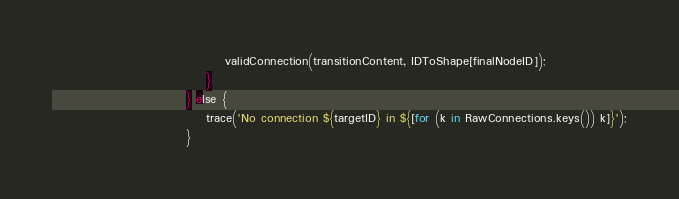Convert code to text. <code><loc_0><loc_0><loc_500><loc_500><_Haxe_>                                    validConnection(transitionContent, IDToShape[finalNodeID]);
                                }    
                            } else {
                                trace('No connection ${targetID} in ${[for (k in RawConnections.keys()) k]}');
                            }</code> 